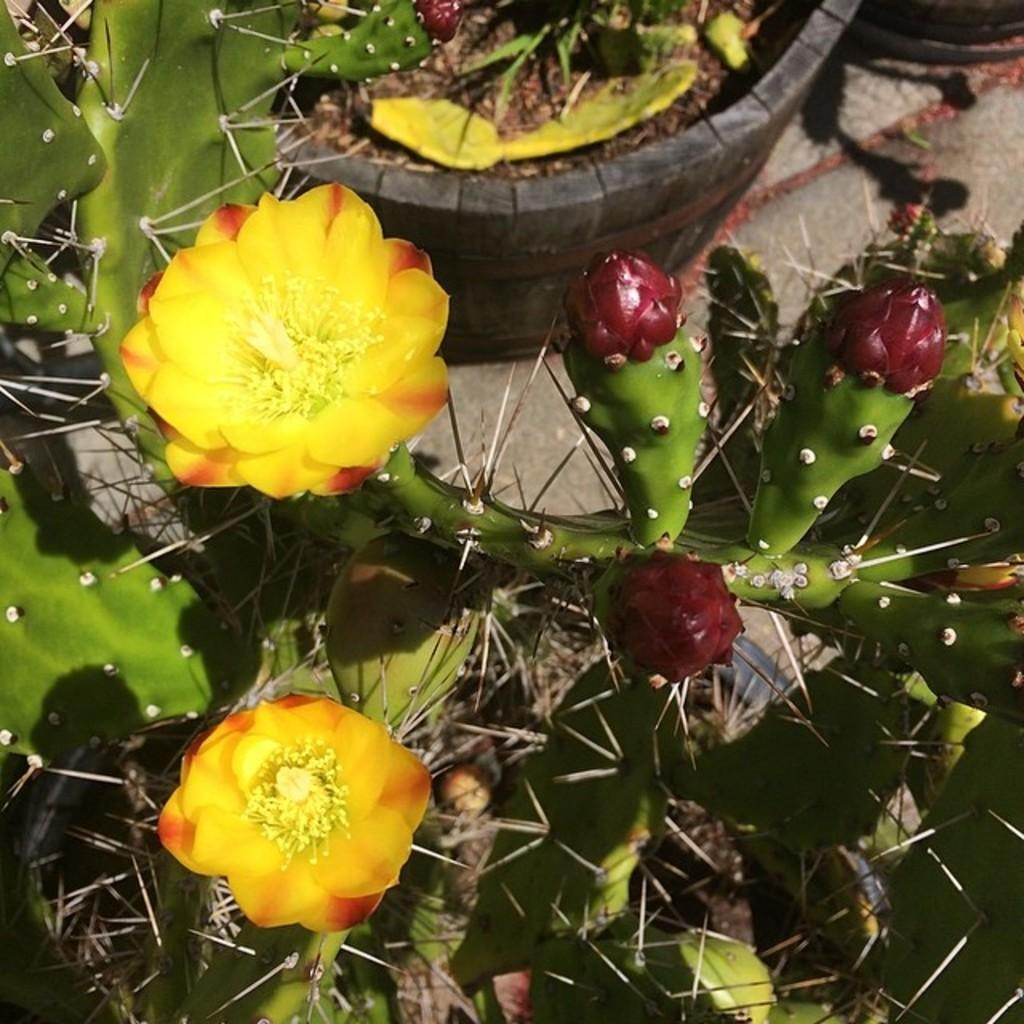What type of flora can be seen in the image? There are flowers and plants in the image. What are the plants contained in? There are pots on the ground in the image. How many bikes are parked next to the plants in the image? There are no bikes present in the image. What type of cable can be seen connecting the flowers in the image? There is no cable present in the image; it only features flowers, plants, and pots. 